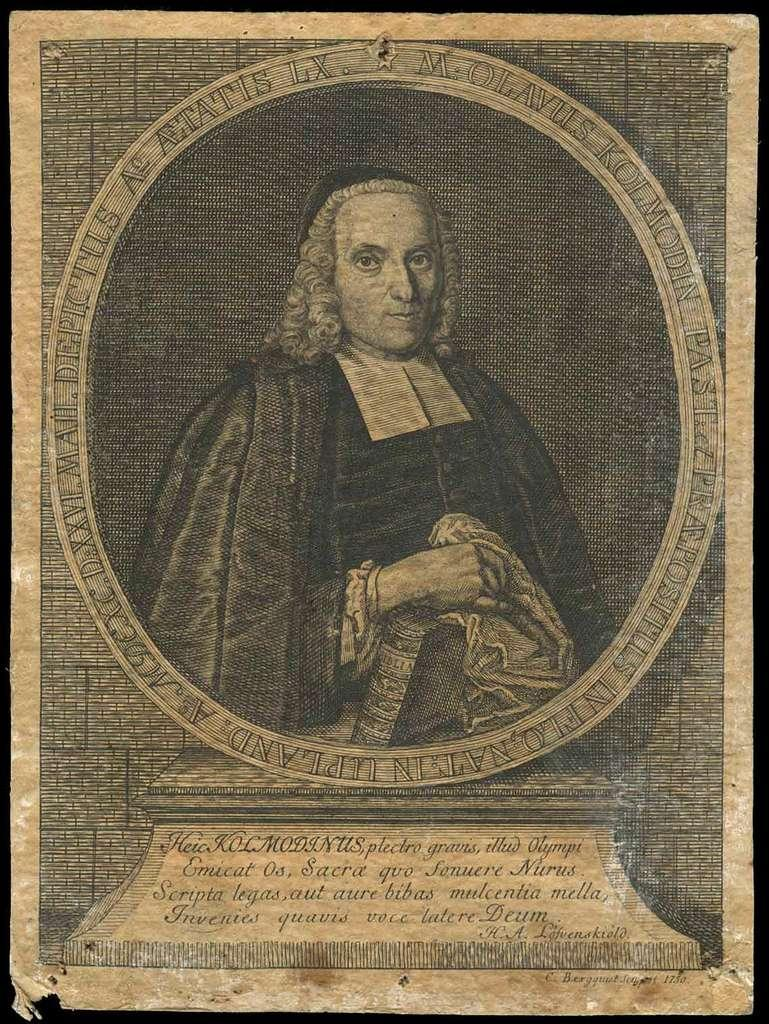<image>
Create a compact narrative representing the image presented. An image from a book published in 1750 shows a man surrounded by a circle of text. 